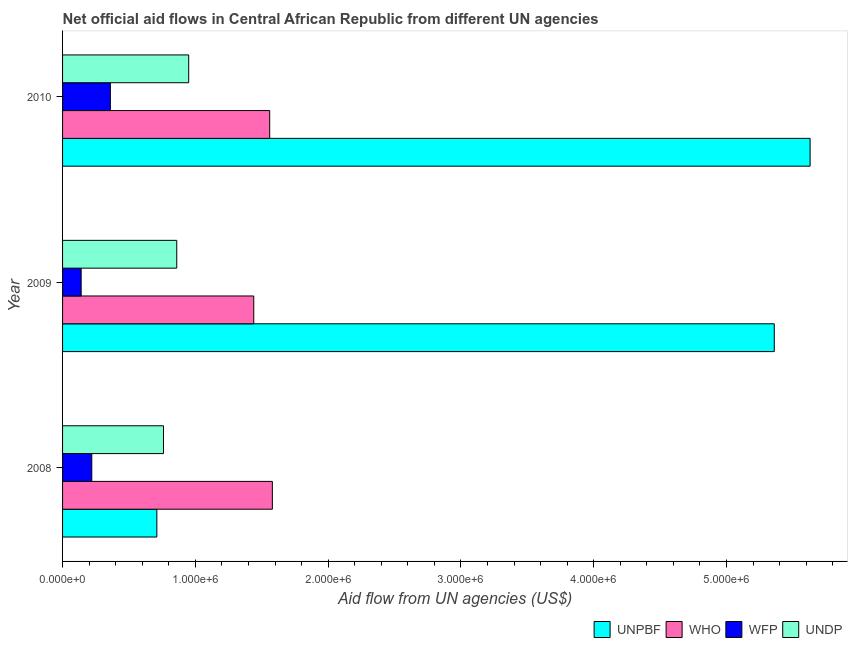How many different coloured bars are there?
Keep it short and to the point. 4. Are the number of bars per tick equal to the number of legend labels?
Your response must be concise. Yes. Are the number of bars on each tick of the Y-axis equal?
Provide a short and direct response. Yes. In how many cases, is the number of bars for a given year not equal to the number of legend labels?
Offer a terse response. 0. What is the amount of aid given by who in 2009?
Offer a terse response. 1.44e+06. Across all years, what is the maximum amount of aid given by wfp?
Your answer should be very brief. 3.60e+05. Across all years, what is the minimum amount of aid given by who?
Ensure brevity in your answer.  1.44e+06. In which year was the amount of aid given by wfp maximum?
Provide a succinct answer. 2010. What is the total amount of aid given by unpbf in the graph?
Your answer should be compact. 1.17e+07. What is the difference between the amount of aid given by wfp in 2009 and that in 2010?
Offer a terse response. -2.20e+05. What is the difference between the amount of aid given by unpbf in 2010 and the amount of aid given by undp in 2009?
Provide a short and direct response. 4.77e+06. What is the average amount of aid given by wfp per year?
Your response must be concise. 2.40e+05. In the year 2009, what is the difference between the amount of aid given by who and amount of aid given by unpbf?
Your response must be concise. -3.92e+06. Is the difference between the amount of aid given by unpbf in 2008 and 2010 greater than the difference between the amount of aid given by wfp in 2008 and 2010?
Your response must be concise. No. What is the difference between the highest and the second highest amount of aid given by wfp?
Offer a very short reply. 1.40e+05. What is the difference between the highest and the lowest amount of aid given by who?
Ensure brevity in your answer.  1.40e+05. In how many years, is the amount of aid given by wfp greater than the average amount of aid given by wfp taken over all years?
Keep it short and to the point. 1. Is it the case that in every year, the sum of the amount of aid given by who and amount of aid given by wfp is greater than the sum of amount of aid given by unpbf and amount of aid given by undp?
Provide a short and direct response. Yes. What does the 4th bar from the top in 2009 represents?
Offer a very short reply. UNPBF. What does the 1st bar from the bottom in 2010 represents?
Offer a terse response. UNPBF. Does the graph contain any zero values?
Make the answer very short. No. Where does the legend appear in the graph?
Your answer should be compact. Bottom right. How many legend labels are there?
Make the answer very short. 4. What is the title of the graph?
Keep it short and to the point. Net official aid flows in Central African Republic from different UN agencies. Does "Second 20% of population" appear as one of the legend labels in the graph?
Your answer should be compact. No. What is the label or title of the X-axis?
Provide a short and direct response. Aid flow from UN agencies (US$). What is the label or title of the Y-axis?
Your answer should be very brief. Year. What is the Aid flow from UN agencies (US$) of UNPBF in 2008?
Give a very brief answer. 7.10e+05. What is the Aid flow from UN agencies (US$) of WHO in 2008?
Your response must be concise. 1.58e+06. What is the Aid flow from UN agencies (US$) in WFP in 2008?
Your answer should be compact. 2.20e+05. What is the Aid flow from UN agencies (US$) of UNDP in 2008?
Your answer should be very brief. 7.60e+05. What is the Aid flow from UN agencies (US$) of UNPBF in 2009?
Provide a succinct answer. 5.36e+06. What is the Aid flow from UN agencies (US$) of WHO in 2009?
Ensure brevity in your answer.  1.44e+06. What is the Aid flow from UN agencies (US$) of WFP in 2009?
Give a very brief answer. 1.40e+05. What is the Aid flow from UN agencies (US$) in UNDP in 2009?
Offer a very short reply. 8.60e+05. What is the Aid flow from UN agencies (US$) in UNPBF in 2010?
Provide a succinct answer. 5.63e+06. What is the Aid flow from UN agencies (US$) of WHO in 2010?
Provide a succinct answer. 1.56e+06. What is the Aid flow from UN agencies (US$) in UNDP in 2010?
Offer a very short reply. 9.50e+05. Across all years, what is the maximum Aid flow from UN agencies (US$) in UNPBF?
Your answer should be very brief. 5.63e+06. Across all years, what is the maximum Aid flow from UN agencies (US$) of WHO?
Offer a terse response. 1.58e+06. Across all years, what is the maximum Aid flow from UN agencies (US$) of WFP?
Give a very brief answer. 3.60e+05. Across all years, what is the maximum Aid flow from UN agencies (US$) of UNDP?
Provide a short and direct response. 9.50e+05. Across all years, what is the minimum Aid flow from UN agencies (US$) in UNPBF?
Give a very brief answer. 7.10e+05. Across all years, what is the minimum Aid flow from UN agencies (US$) of WHO?
Your answer should be very brief. 1.44e+06. Across all years, what is the minimum Aid flow from UN agencies (US$) in UNDP?
Offer a very short reply. 7.60e+05. What is the total Aid flow from UN agencies (US$) of UNPBF in the graph?
Keep it short and to the point. 1.17e+07. What is the total Aid flow from UN agencies (US$) in WHO in the graph?
Offer a very short reply. 4.58e+06. What is the total Aid flow from UN agencies (US$) of WFP in the graph?
Offer a terse response. 7.20e+05. What is the total Aid flow from UN agencies (US$) of UNDP in the graph?
Make the answer very short. 2.57e+06. What is the difference between the Aid flow from UN agencies (US$) of UNPBF in 2008 and that in 2009?
Provide a succinct answer. -4.65e+06. What is the difference between the Aid flow from UN agencies (US$) of WFP in 2008 and that in 2009?
Keep it short and to the point. 8.00e+04. What is the difference between the Aid flow from UN agencies (US$) in UNDP in 2008 and that in 2009?
Ensure brevity in your answer.  -1.00e+05. What is the difference between the Aid flow from UN agencies (US$) in UNPBF in 2008 and that in 2010?
Ensure brevity in your answer.  -4.92e+06. What is the difference between the Aid flow from UN agencies (US$) in WFP in 2008 and that in 2010?
Ensure brevity in your answer.  -1.40e+05. What is the difference between the Aid flow from UN agencies (US$) in UNPBF in 2009 and that in 2010?
Your answer should be compact. -2.70e+05. What is the difference between the Aid flow from UN agencies (US$) in WHO in 2009 and that in 2010?
Give a very brief answer. -1.20e+05. What is the difference between the Aid flow from UN agencies (US$) in WFP in 2009 and that in 2010?
Your response must be concise. -2.20e+05. What is the difference between the Aid flow from UN agencies (US$) of UNDP in 2009 and that in 2010?
Ensure brevity in your answer.  -9.00e+04. What is the difference between the Aid flow from UN agencies (US$) in UNPBF in 2008 and the Aid flow from UN agencies (US$) in WHO in 2009?
Offer a terse response. -7.30e+05. What is the difference between the Aid flow from UN agencies (US$) of UNPBF in 2008 and the Aid flow from UN agencies (US$) of WFP in 2009?
Keep it short and to the point. 5.70e+05. What is the difference between the Aid flow from UN agencies (US$) of UNPBF in 2008 and the Aid flow from UN agencies (US$) of UNDP in 2009?
Provide a short and direct response. -1.50e+05. What is the difference between the Aid flow from UN agencies (US$) of WHO in 2008 and the Aid flow from UN agencies (US$) of WFP in 2009?
Offer a very short reply. 1.44e+06. What is the difference between the Aid flow from UN agencies (US$) in WHO in 2008 and the Aid flow from UN agencies (US$) in UNDP in 2009?
Keep it short and to the point. 7.20e+05. What is the difference between the Aid flow from UN agencies (US$) of WFP in 2008 and the Aid flow from UN agencies (US$) of UNDP in 2009?
Offer a very short reply. -6.40e+05. What is the difference between the Aid flow from UN agencies (US$) in UNPBF in 2008 and the Aid flow from UN agencies (US$) in WHO in 2010?
Your response must be concise. -8.50e+05. What is the difference between the Aid flow from UN agencies (US$) in UNPBF in 2008 and the Aid flow from UN agencies (US$) in WFP in 2010?
Your answer should be very brief. 3.50e+05. What is the difference between the Aid flow from UN agencies (US$) of WHO in 2008 and the Aid flow from UN agencies (US$) of WFP in 2010?
Keep it short and to the point. 1.22e+06. What is the difference between the Aid flow from UN agencies (US$) of WHO in 2008 and the Aid flow from UN agencies (US$) of UNDP in 2010?
Your answer should be very brief. 6.30e+05. What is the difference between the Aid flow from UN agencies (US$) in WFP in 2008 and the Aid flow from UN agencies (US$) in UNDP in 2010?
Offer a terse response. -7.30e+05. What is the difference between the Aid flow from UN agencies (US$) of UNPBF in 2009 and the Aid flow from UN agencies (US$) of WHO in 2010?
Keep it short and to the point. 3.80e+06. What is the difference between the Aid flow from UN agencies (US$) in UNPBF in 2009 and the Aid flow from UN agencies (US$) in UNDP in 2010?
Keep it short and to the point. 4.41e+06. What is the difference between the Aid flow from UN agencies (US$) in WHO in 2009 and the Aid flow from UN agencies (US$) in WFP in 2010?
Your answer should be very brief. 1.08e+06. What is the difference between the Aid flow from UN agencies (US$) of WHO in 2009 and the Aid flow from UN agencies (US$) of UNDP in 2010?
Give a very brief answer. 4.90e+05. What is the difference between the Aid flow from UN agencies (US$) in WFP in 2009 and the Aid flow from UN agencies (US$) in UNDP in 2010?
Provide a short and direct response. -8.10e+05. What is the average Aid flow from UN agencies (US$) of UNPBF per year?
Provide a succinct answer. 3.90e+06. What is the average Aid flow from UN agencies (US$) of WHO per year?
Ensure brevity in your answer.  1.53e+06. What is the average Aid flow from UN agencies (US$) of UNDP per year?
Give a very brief answer. 8.57e+05. In the year 2008, what is the difference between the Aid flow from UN agencies (US$) of UNPBF and Aid flow from UN agencies (US$) of WHO?
Provide a short and direct response. -8.70e+05. In the year 2008, what is the difference between the Aid flow from UN agencies (US$) in UNPBF and Aid flow from UN agencies (US$) in WFP?
Your answer should be compact. 4.90e+05. In the year 2008, what is the difference between the Aid flow from UN agencies (US$) of UNPBF and Aid flow from UN agencies (US$) of UNDP?
Keep it short and to the point. -5.00e+04. In the year 2008, what is the difference between the Aid flow from UN agencies (US$) of WHO and Aid flow from UN agencies (US$) of WFP?
Offer a very short reply. 1.36e+06. In the year 2008, what is the difference between the Aid flow from UN agencies (US$) of WHO and Aid flow from UN agencies (US$) of UNDP?
Provide a succinct answer. 8.20e+05. In the year 2008, what is the difference between the Aid flow from UN agencies (US$) of WFP and Aid flow from UN agencies (US$) of UNDP?
Your response must be concise. -5.40e+05. In the year 2009, what is the difference between the Aid flow from UN agencies (US$) in UNPBF and Aid flow from UN agencies (US$) in WHO?
Provide a short and direct response. 3.92e+06. In the year 2009, what is the difference between the Aid flow from UN agencies (US$) in UNPBF and Aid flow from UN agencies (US$) in WFP?
Keep it short and to the point. 5.22e+06. In the year 2009, what is the difference between the Aid flow from UN agencies (US$) in UNPBF and Aid flow from UN agencies (US$) in UNDP?
Offer a very short reply. 4.50e+06. In the year 2009, what is the difference between the Aid flow from UN agencies (US$) of WHO and Aid flow from UN agencies (US$) of WFP?
Offer a very short reply. 1.30e+06. In the year 2009, what is the difference between the Aid flow from UN agencies (US$) in WHO and Aid flow from UN agencies (US$) in UNDP?
Offer a very short reply. 5.80e+05. In the year 2009, what is the difference between the Aid flow from UN agencies (US$) in WFP and Aid flow from UN agencies (US$) in UNDP?
Offer a very short reply. -7.20e+05. In the year 2010, what is the difference between the Aid flow from UN agencies (US$) of UNPBF and Aid flow from UN agencies (US$) of WHO?
Ensure brevity in your answer.  4.07e+06. In the year 2010, what is the difference between the Aid flow from UN agencies (US$) in UNPBF and Aid flow from UN agencies (US$) in WFP?
Your response must be concise. 5.27e+06. In the year 2010, what is the difference between the Aid flow from UN agencies (US$) in UNPBF and Aid flow from UN agencies (US$) in UNDP?
Your answer should be compact. 4.68e+06. In the year 2010, what is the difference between the Aid flow from UN agencies (US$) in WHO and Aid flow from UN agencies (US$) in WFP?
Give a very brief answer. 1.20e+06. In the year 2010, what is the difference between the Aid flow from UN agencies (US$) of WFP and Aid flow from UN agencies (US$) of UNDP?
Keep it short and to the point. -5.90e+05. What is the ratio of the Aid flow from UN agencies (US$) of UNPBF in 2008 to that in 2009?
Offer a very short reply. 0.13. What is the ratio of the Aid flow from UN agencies (US$) in WHO in 2008 to that in 2009?
Provide a short and direct response. 1.1. What is the ratio of the Aid flow from UN agencies (US$) of WFP in 2008 to that in 2009?
Offer a very short reply. 1.57. What is the ratio of the Aid flow from UN agencies (US$) in UNDP in 2008 to that in 2009?
Make the answer very short. 0.88. What is the ratio of the Aid flow from UN agencies (US$) in UNPBF in 2008 to that in 2010?
Your response must be concise. 0.13. What is the ratio of the Aid flow from UN agencies (US$) in WHO in 2008 to that in 2010?
Make the answer very short. 1.01. What is the ratio of the Aid flow from UN agencies (US$) in WFP in 2008 to that in 2010?
Offer a very short reply. 0.61. What is the ratio of the Aid flow from UN agencies (US$) in WHO in 2009 to that in 2010?
Make the answer very short. 0.92. What is the ratio of the Aid flow from UN agencies (US$) of WFP in 2009 to that in 2010?
Your answer should be very brief. 0.39. What is the ratio of the Aid flow from UN agencies (US$) of UNDP in 2009 to that in 2010?
Provide a succinct answer. 0.91. What is the difference between the highest and the second highest Aid flow from UN agencies (US$) in UNPBF?
Give a very brief answer. 2.70e+05. What is the difference between the highest and the lowest Aid flow from UN agencies (US$) in UNPBF?
Ensure brevity in your answer.  4.92e+06. What is the difference between the highest and the lowest Aid flow from UN agencies (US$) in WHO?
Give a very brief answer. 1.40e+05. What is the difference between the highest and the lowest Aid flow from UN agencies (US$) of WFP?
Give a very brief answer. 2.20e+05. 